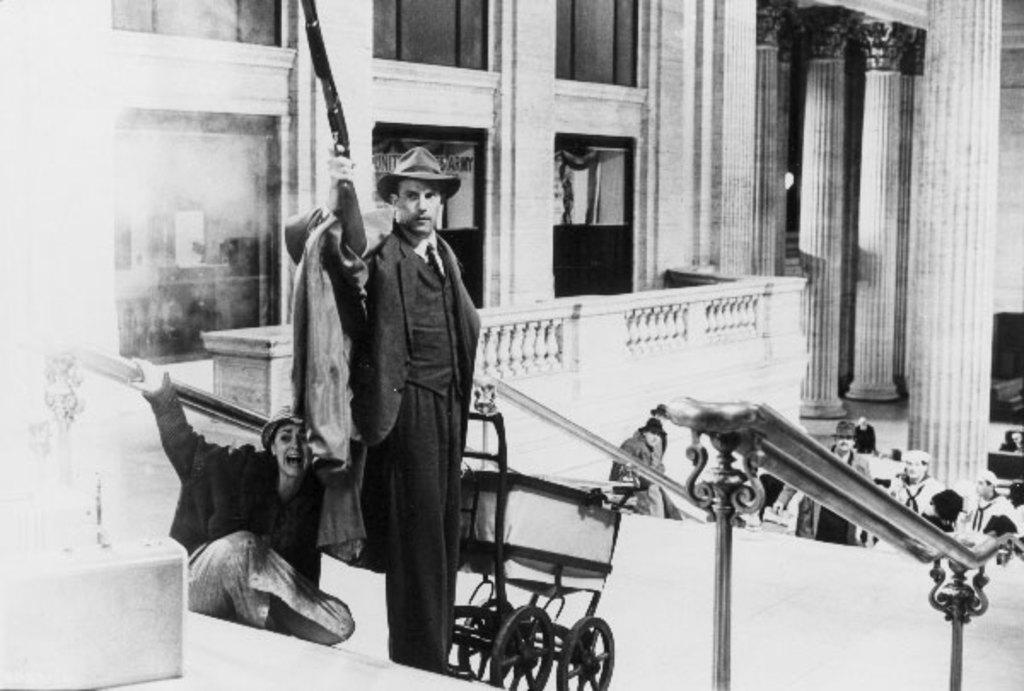What is the color scheme of the image? The image is black and white. Can you describe the subjects in the image? There are people in the image. What is a person doing in the image? A person is holding a gun in the image. What architectural features can be seen in the image? There are pillars in the image. What type of food is the cook preparing in the image? There is no cook or food preparation visible in the image. What is the purpose of the wristband on the person's wrist in the image? There is no wristband visible on any person in the image. 